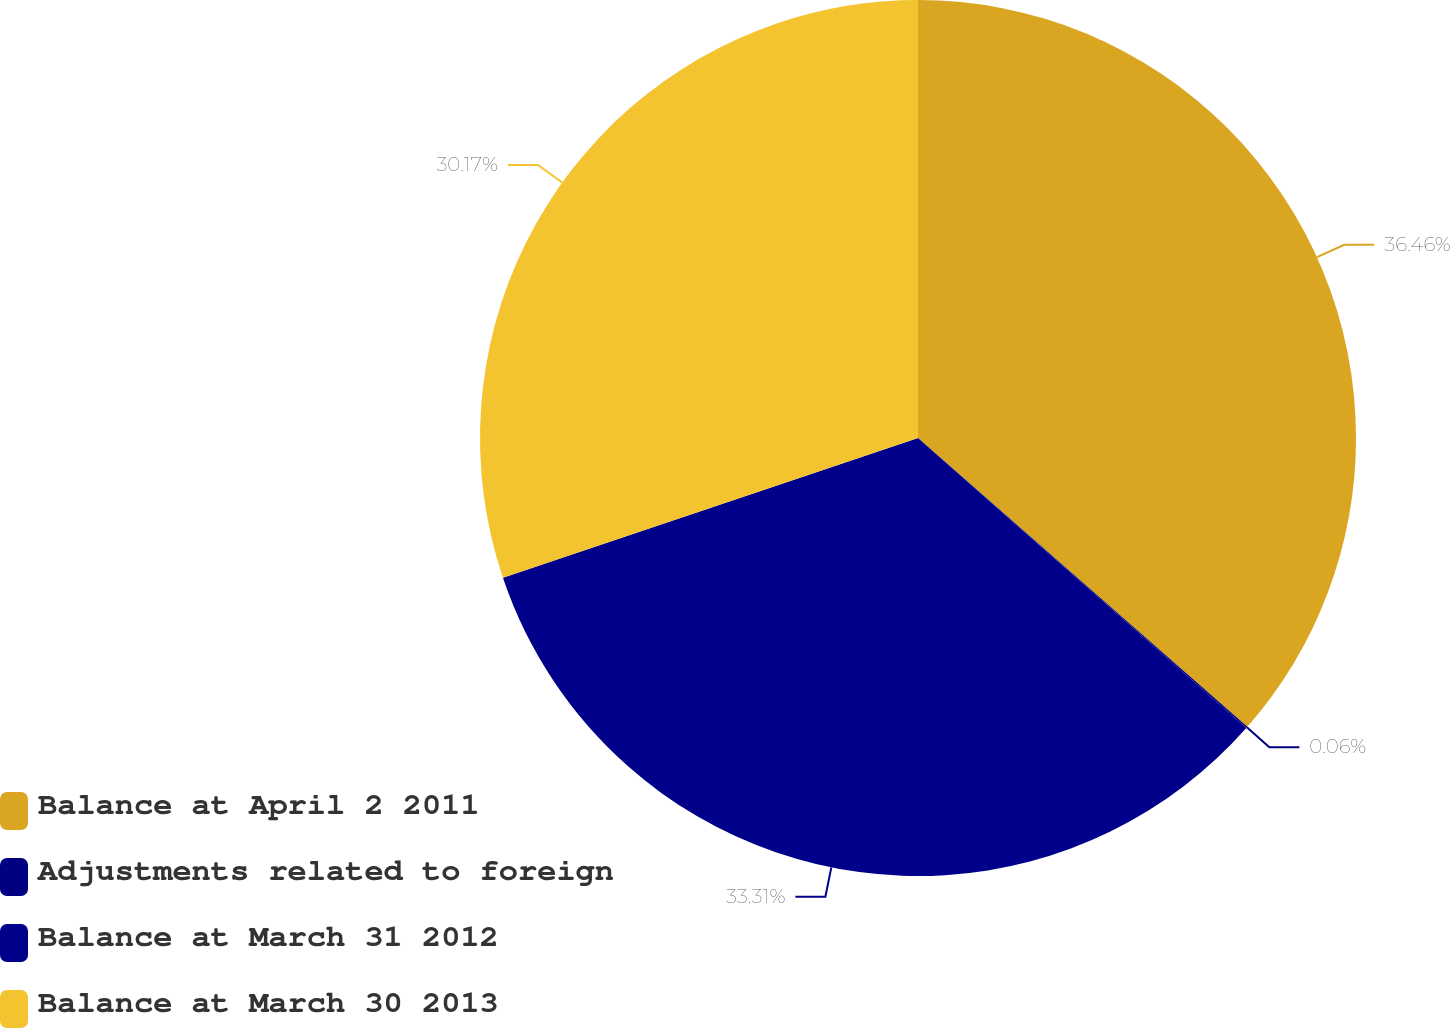<chart> <loc_0><loc_0><loc_500><loc_500><pie_chart><fcel>Balance at April 2 2011<fcel>Adjustments related to foreign<fcel>Balance at March 31 2012<fcel>Balance at March 30 2013<nl><fcel>36.45%<fcel>0.06%<fcel>33.31%<fcel>30.17%<nl></chart> 